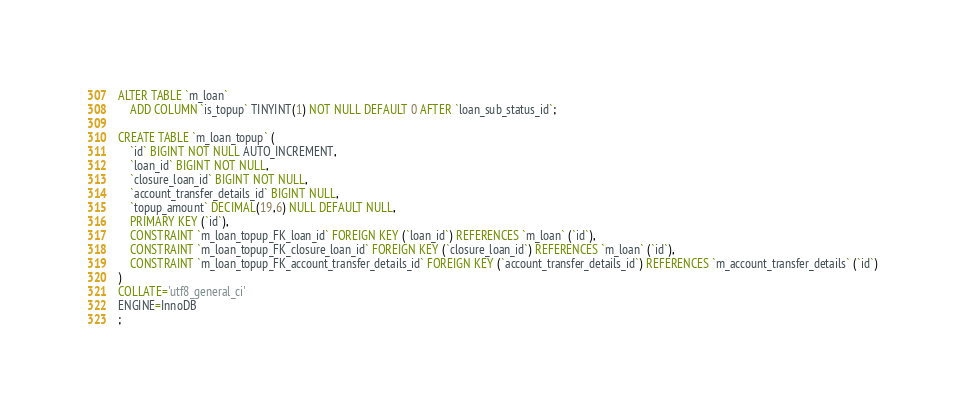Convert code to text. <code><loc_0><loc_0><loc_500><loc_500><_SQL_>
ALTER TABLE `m_loan`
	ADD COLUMN `is_topup` TINYINT(1) NOT NULL DEFAULT 0 AFTER `loan_sub_status_id`;

CREATE TABLE `m_loan_topup` (
	`id` BIGINT NOT NULL AUTO_INCREMENT,
	`loan_id` BIGINT NOT NULL,
	`closure_loan_id` BIGINT NOT NULL,
	`account_transfer_details_id` BIGINT NULL,
	`topup_amount` DECIMAL(19,6) NULL DEFAULT NULL,
	PRIMARY KEY (`id`),
	CONSTRAINT `m_loan_topup_FK_loan_id` FOREIGN KEY (`loan_id`) REFERENCES `m_loan` (`id`),
	CONSTRAINT `m_loan_topup_FK_closure_loan_id` FOREIGN KEY (`closure_loan_id`) REFERENCES `m_loan` (`id`),
	CONSTRAINT `m_loan_topup_FK_account_transfer_details_id` FOREIGN KEY (`account_transfer_details_id`) REFERENCES `m_account_transfer_details` (`id`)
)
COLLATE='utf8_general_ci'
ENGINE=InnoDB
;

</code> 